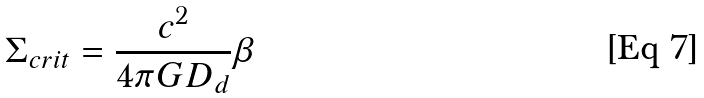Convert formula to latex. <formula><loc_0><loc_0><loc_500><loc_500>\Sigma _ { c r i t } = \frac { c ^ { 2 } } { 4 \pi G D _ { d } } \beta</formula> 